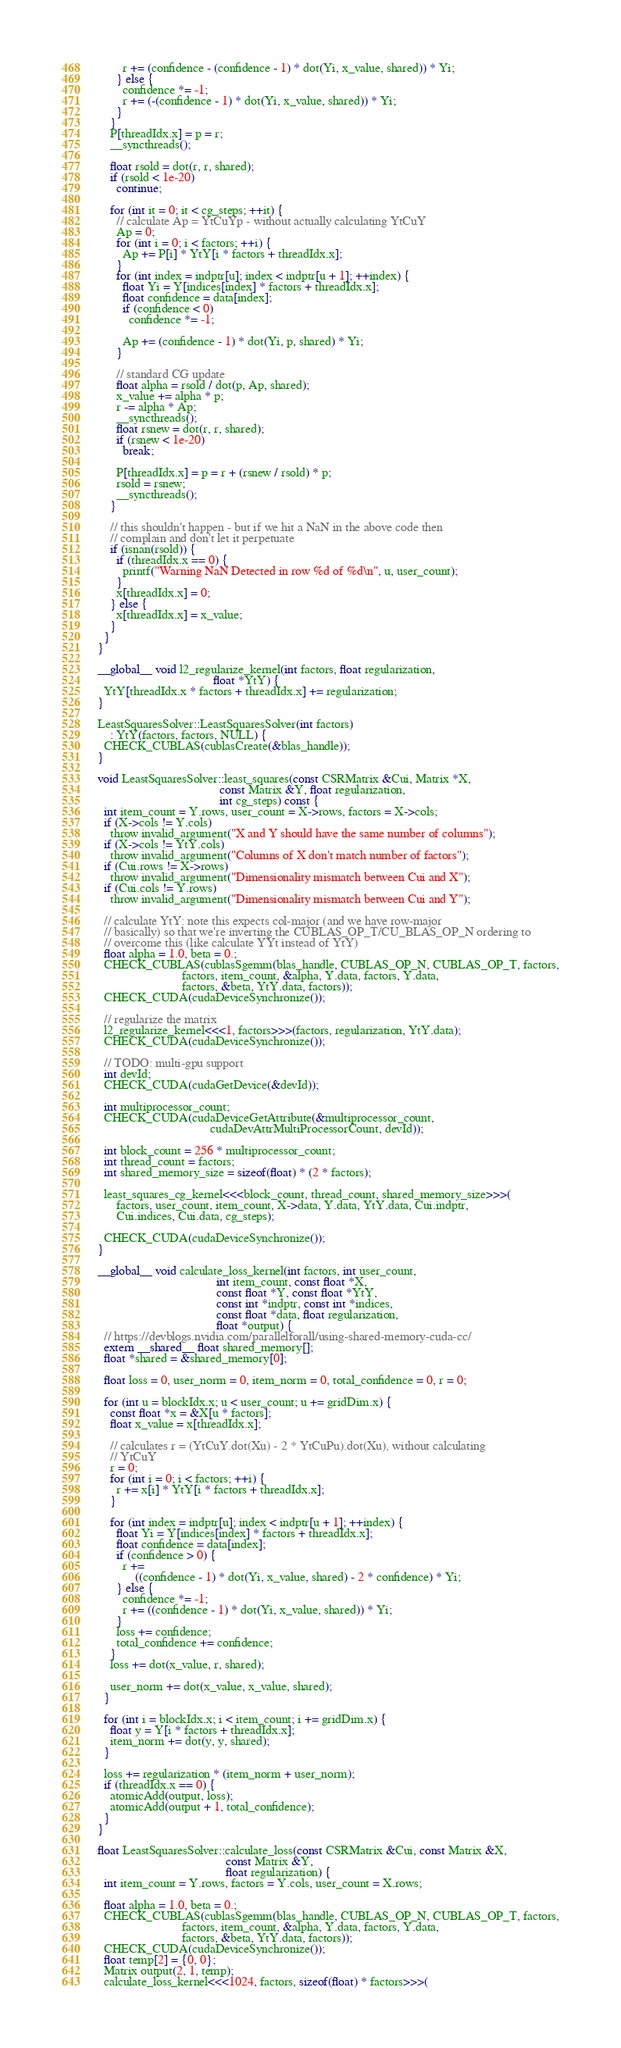<code> <loc_0><loc_0><loc_500><loc_500><_Cuda_>        r += (confidence - (confidence - 1) * dot(Yi, x_value, shared)) * Yi;
      } else {
        confidence *= -1;
        r += (-(confidence - 1) * dot(Yi, x_value, shared)) * Yi;
      }
    }
    P[threadIdx.x] = p = r;
    __syncthreads();

    float rsold = dot(r, r, shared);
    if (rsold < 1e-20)
      continue;

    for (int it = 0; it < cg_steps; ++it) {
      // calculate Ap = YtCuYp - without actually calculating YtCuY
      Ap = 0;
      for (int i = 0; i < factors; ++i) {
        Ap += P[i] * YtY[i * factors + threadIdx.x];
      }
      for (int index = indptr[u]; index < indptr[u + 1]; ++index) {
        float Yi = Y[indices[index] * factors + threadIdx.x];
        float confidence = data[index];
        if (confidence < 0)
          confidence *= -1;

        Ap += (confidence - 1) * dot(Yi, p, shared) * Yi;
      }

      // standard CG update
      float alpha = rsold / dot(p, Ap, shared);
      x_value += alpha * p;
      r -= alpha * Ap;
      __syncthreads();
      float rsnew = dot(r, r, shared);
      if (rsnew < 1e-20)
        break;

      P[threadIdx.x] = p = r + (rsnew / rsold) * p;
      rsold = rsnew;
      __syncthreads();
    }

    // this shouldn't happen - but if we hit a NaN in the above code then
    // complain and don't let it perpetuate
    if (isnan(rsold)) {
      if (threadIdx.x == 0) {
        printf("Warning NaN Detected in row %d of %d\n", u, user_count);
      }
      x[threadIdx.x] = 0;
    } else {
      x[threadIdx.x] = x_value;
    }
  }
}

__global__ void l2_regularize_kernel(int factors, float regularization,
                                     float *YtY) {
  YtY[threadIdx.x * factors + threadIdx.x] += regularization;
}

LeastSquaresSolver::LeastSquaresSolver(int factors)
    : YtY(factors, factors, NULL) {
  CHECK_CUBLAS(cublasCreate(&blas_handle));
}

void LeastSquaresSolver::least_squares(const CSRMatrix &Cui, Matrix *X,
                                       const Matrix &Y, float regularization,
                                       int cg_steps) const {
  int item_count = Y.rows, user_count = X->rows, factors = X->cols;
  if (X->cols != Y.cols)
    throw invalid_argument("X and Y should have the same number of columns");
  if (X->cols != YtY.cols)
    throw invalid_argument("Columns of X don't match number of factors");
  if (Cui.rows != X->rows)
    throw invalid_argument("Dimensionality mismatch between Cui and X");
  if (Cui.cols != Y.rows)
    throw invalid_argument("Dimensionality mismatch between Cui and Y");

  // calculate YtY: note this expects col-major (and we have row-major
  // basically) so that we're inverting the CUBLAS_OP_T/CU_BLAS_OP_N ordering to
  // overcome this (like calculate YYt instead of YtY)
  float alpha = 1.0, beta = 0.;
  CHECK_CUBLAS(cublasSgemm(blas_handle, CUBLAS_OP_N, CUBLAS_OP_T, factors,
                           factors, item_count, &alpha, Y.data, factors, Y.data,
                           factors, &beta, YtY.data, factors));
  CHECK_CUDA(cudaDeviceSynchronize());

  // regularize the matrix
  l2_regularize_kernel<<<1, factors>>>(factors, regularization, YtY.data);
  CHECK_CUDA(cudaDeviceSynchronize());

  // TODO: multi-gpu support
  int devId;
  CHECK_CUDA(cudaGetDevice(&devId));

  int multiprocessor_count;
  CHECK_CUDA(cudaDeviceGetAttribute(&multiprocessor_count,
                                    cudaDevAttrMultiProcessorCount, devId));

  int block_count = 256 * multiprocessor_count;
  int thread_count = factors;
  int shared_memory_size = sizeof(float) * (2 * factors);

  least_squares_cg_kernel<<<block_count, thread_count, shared_memory_size>>>(
      factors, user_count, item_count, X->data, Y.data, YtY.data, Cui.indptr,
      Cui.indices, Cui.data, cg_steps);

  CHECK_CUDA(cudaDeviceSynchronize());
}

__global__ void calculate_loss_kernel(int factors, int user_count,
                                      int item_count, const float *X,
                                      const float *Y, const float *YtY,
                                      const int *indptr, const int *indices,
                                      const float *data, float regularization,
                                      float *output) {
  // https://devblogs.nvidia.com/parallelforall/using-shared-memory-cuda-cc/
  extern __shared__ float shared_memory[];
  float *shared = &shared_memory[0];

  float loss = 0, user_norm = 0, item_norm = 0, total_confidence = 0, r = 0;

  for (int u = blockIdx.x; u < user_count; u += gridDim.x) {
    const float *x = &X[u * factors];
    float x_value = x[threadIdx.x];

    // calculates r = (YtCuY.dot(Xu) - 2 * YtCuPu).dot(Xu), without calculating
    // YtCuY
    r = 0;
    for (int i = 0; i < factors; ++i) {
      r += x[i] * YtY[i * factors + threadIdx.x];
    }

    for (int index = indptr[u]; index < indptr[u + 1]; ++index) {
      float Yi = Y[indices[index] * factors + threadIdx.x];
      float confidence = data[index];
      if (confidence > 0) {
        r +=
            ((confidence - 1) * dot(Yi, x_value, shared) - 2 * confidence) * Yi;
      } else {
        confidence *= -1;
        r += ((confidence - 1) * dot(Yi, x_value, shared)) * Yi;
      }
      loss += confidence;
      total_confidence += confidence;
    }
    loss += dot(x_value, r, shared);

    user_norm += dot(x_value, x_value, shared);
  }

  for (int i = blockIdx.x; i < item_count; i += gridDim.x) {
    float y = Y[i * factors + threadIdx.x];
    item_norm += dot(y, y, shared);
  }

  loss += regularization * (item_norm + user_norm);
  if (threadIdx.x == 0) {
    atomicAdd(output, loss);
    atomicAdd(output + 1, total_confidence);
  }
}

float LeastSquaresSolver::calculate_loss(const CSRMatrix &Cui, const Matrix &X,
                                         const Matrix &Y,
                                         float regularization) {
  int item_count = Y.rows, factors = Y.cols, user_count = X.rows;

  float alpha = 1.0, beta = 0.;
  CHECK_CUBLAS(cublasSgemm(blas_handle, CUBLAS_OP_N, CUBLAS_OP_T, factors,
                           factors, item_count, &alpha, Y.data, factors, Y.data,
                           factors, &beta, YtY.data, factors));
  CHECK_CUDA(cudaDeviceSynchronize());
  float temp[2] = {0, 0};
  Matrix output(2, 1, temp);
  calculate_loss_kernel<<<1024, factors, sizeof(float) * factors>>>(</code> 